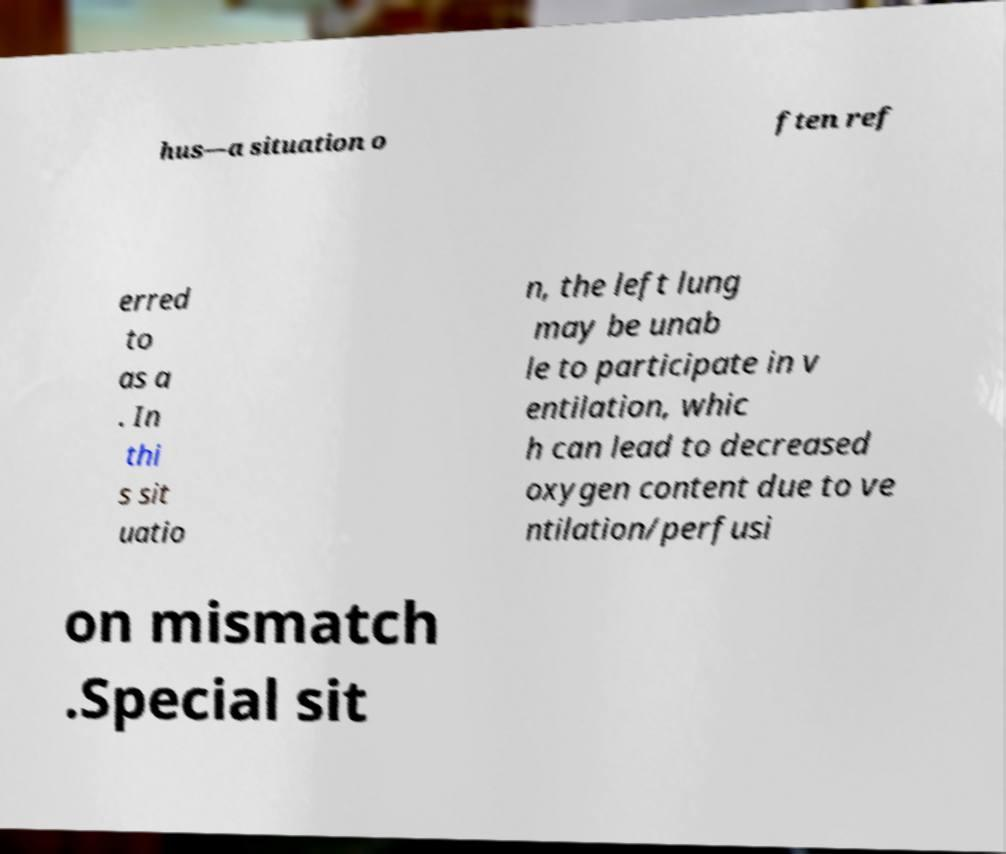Please identify and transcribe the text found in this image. hus—a situation o ften ref erred to as a . In thi s sit uatio n, the left lung may be unab le to participate in v entilation, whic h can lead to decreased oxygen content due to ve ntilation/perfusi on mismatch .Special sit 